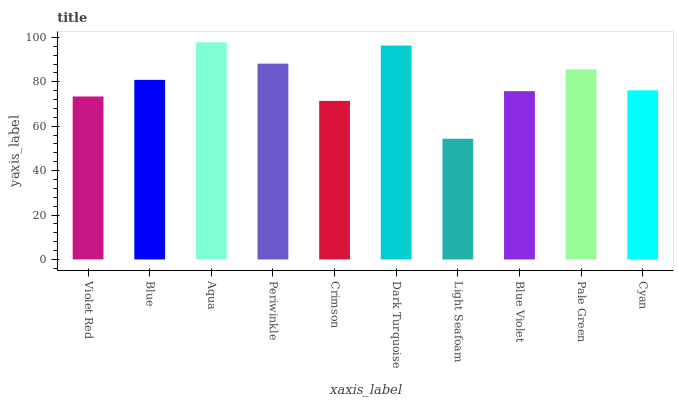Is Blue the minimum?
Answer yes or no. No. Is Blue the maximum?
Answer yes or no. No. Is Blue greater than Violet Red?
Answer yes or no. Yes. Is Violet Red less than Blue?
Answer yes or no. Yes. Is Violet Red greater than Blue?
Answer yes or no. No. Is Blue less than Violet Red?
Answer yes or no. No. Is Blue the high median?
Answer yes or no. Yes. Is Cyan the low median?
Answer yes or no. Yes. Is Violet Red the high median?
Answer yes or no. No. Is Dark Turquoise the low median?
Answer yes or no. No. 